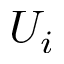<formula> <loc_0><loc_0><loc_500><loc_500>U _ { i }</formula> 